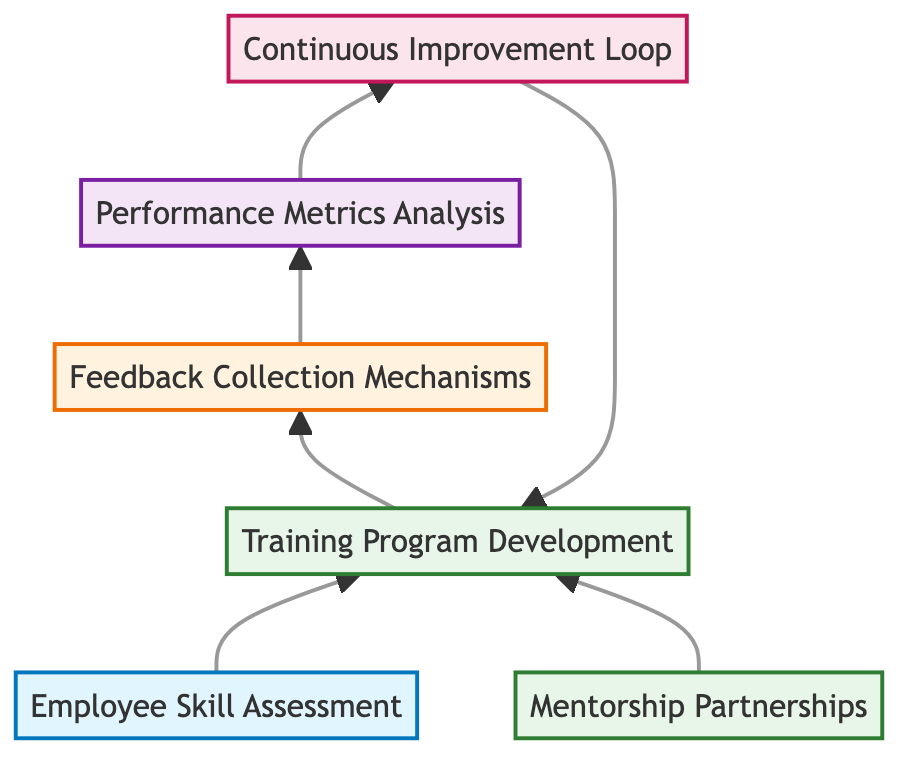what is the first step in the process? The first step in the process is "Employee Skill Assessment," which is represented as the starting node in the flow chart.
Answer: Employee Skill Assessment how many nodes are present in the diagram? There are a total of six nodes present in the diagram, each representing different aspects of the employee training and development programs.
Answer: 6 which node comes after "Training Program Development"? The node that comes after "Training Program Development" is "Feedback Collection Mechanisms," as it is the next step in the flow process indicated by the arrows.
Answer: Feedback Collection Mechanisms how does "Feedback Collection Mechanisms" connect to "Performance Metrics Analysis"? "Feedback Collection Mechanisms" connects to "Performance Metrics Analysis" as a sequential step where feedback is analyzed to assess training effectiveness, indicated by the arrows in the flow chart.
Answer: Through an arrow name a node that loops back to "Training Program Development." The node "Continuous Improvement Loop" loops back to "Training Program Development," suggesting ongoing enhancements based on feedback.
Answer: Continuous Improvement Loop which two nodes are directly connected by the "Mentorship Partnerships" node? "Mentorship Partnerships" is directly connected to "Training Program Development," indicating that mentorship opportunities support the training programs.
Answer: Training Program Development and Mentorship Partnerships what type of process is represented by "Continuous Improvement Loop"? "Continuous Improvement Loop" is classified as a process, as indicated by the designation and its function of iterating based on feedback and assessment results.
Answer: Process what is the purpose of the "Performance Metrics Analysis"? The purpose of "Performance Metrics Analysis" is to analyze post-training performance metrics to determine improvements and areas for additional support based on the training received.
Answer: Measure improvement who provides feedback in the "Feedback Collection Mechanisms"? Employees provide feedback in the "Feedback Collection Mechanisms" through surveys and interviews about the effectiveness of the training.
Answer: Employees 